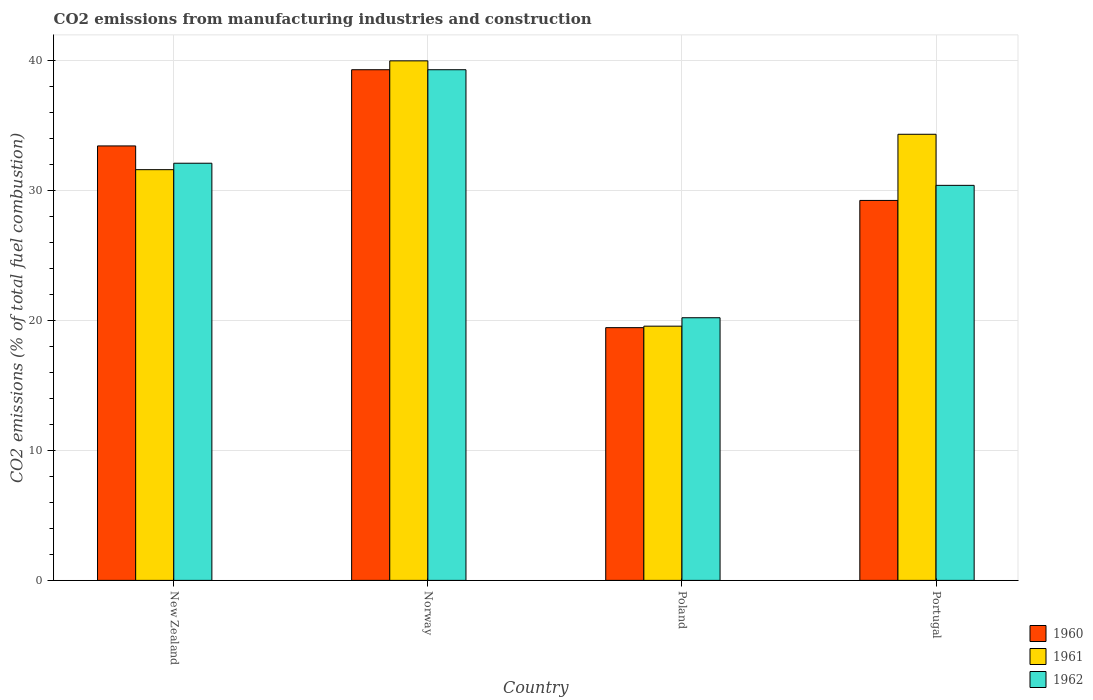How many groups of bars are there?
Ensure brevity in your answer.  4. How many bars are there on the 4th tick from the left?
Your response must be concise. 3. What is the label of the 2nd group of bars from the left?
Provide a succinct answer. Norway. In how many cases, is the number of bars for a given country not equal to the number of legend labels?
Ensure brevity in your answer.  0. What is the amount of CO2 emitted in 1960 in New Zealand?
Your answer should be very brief. 33.4. Across all countries, what is the maximum amount of CO2 emitted in 1962?
Ensure brevity in your answer.  39.26. Across all countries, what is the minimum amount of CO2 emitted in 1962?
Make the answer very short. 20.19. In which country was the amount of CO2 emitted in 1961 maximum?
Provide a short and direct response. Norway. What is the total amount of CO2 emitted in 1962 in the graph?
Your response must be concise. 121.88. What is the difference between the amount of CO2 emitted in 1962 in Norway and that in Poland?
Your answer should be very brief. 19.06. What is the difference between the amount of CO2 emitted in 1960 in Portugal and the amount of CO2 emitted in 1962 in Poland?
Your answer should be very brief. 9.02. What is the average amount of CO2 emitted in 1960 per country?
Provide a short and direct response. 30.32. What is the difference between the amount of CO2 emitted of/in 1960 and amount of CO2 emitted of/in 1961 in Poland?
Give a very brief answer. -0.11. What is the ratio of the amount of CO2 emitted in 1960 in Poland to that in Portugal?
Give a very brief answer. 0.67. What is the difference between the highest and the second highest amount of CO2 emitted in 1961?
Provide a short and direct response. 2.72. What is the difference between the highest and the lowest amount of CO2 emitted in 1961?
Your answer should be compact. 20.39. Is the sum of the amount of CO2 emitted in 1962 in New Zealand and Portugal greater than the maximum amount of CO2 emitted in 1960 across all countries?
Ensure brevity in your answer.  Yes. What does the 3rd bar from the right in Norway represents?
Your response must be concise. 1960. Does the graph contain any zero values?
Your answer should be compact. No. How many legend labels are there?
Offer a very short reply. 3. How are the legend labels stacked?
Offer a terse response. Vertical. What is the title of the graph?
Make the answer very short. CO2 emissions from manufacturing industries and construction. What is the label or title of the X-axis?
Ensure brevity in your answer.  Country. What is the label or title of the Y-axis?
Give a very brief answer. CO2 emissions (% of total fuel combustion). What is the CO2 emissions (% of total fuel combustion) of 1960 in New Zealand?
Give a very brief answer. 33.4. What is the CO2 emissions (% of total fuel combustion) in 1961 in New Zealand?
Provide a succinct answer. 31.57. What is the CO2 emissions (% of total fuel combustion) in 1962 in New Zealand?
Keep it short and to the point. 32.07. What is the CO2 emissions (% of total fuel combustion) in 1960 in Norway?
Provide a short and direct response. 39.26. What is the CO2 emissions (% of total fuel combustion) in 1961 in Norway?
Your answer should be very brief. 39.94. What is the CO2 emissions (% of total fuel combustion) of 1962 in Norway?
Make the answer very short. 39.26. What is the CO2 emissions (% of total fuel combustion) of 1960 in Poland?
Provide a succinct answer. 19.43. What is the CO2 emissions (% of total fuel combustion) in 1961 in Poland?
Provide a short and direct response. 19.54. What is the CO2 emissions (% of total fuel combustion) of 1962 in Poland?
Make the answer very short. 20.19. What is the CO2 emissions (% of total fuel combustion) of 1960 in Portugal?
Your answer should be very brief. 29.21. What is the CO2 emissions (% of total fuel combustion) in 1961 in Portugal?
Your response must be concise. 34.29. What is the CO2 emissions (% of total fuel combustion) of 1962 in Portugal?
Offer a very short reply. 30.37. Across all countries, what is the maximum CO2 emissions (% of total fuel combustion) of 1960?
Provide a short and direct response. 39.26. Across all countries, what is the maximum CO2 emissions (% of total fuel combustion) of 1961?
Your answer should be very brief. 39.94. Across all countries, what is the maximum CO2 emissions (% of total fuel combustion) of 1962?
Your answer should be compact. 39.26. Across all countries, what is the minimum CO2 emissions (% of total fuel combustion) of 1960?
Keep it short and to the point. 19.43. Across all countries, what is the minimum CO2 emissions (% of total fuel combustion) of 1961?
Your response must be concise. 19.54. Across all countries, what is the minimum CO2 emissions (% of total fuel combustion) of 1962?
Keep it short and to the point. 20.19. What is the total CO2 emissions (% of total fuel combustion) of 1960 in the graph?
Make the answer very short. 121.29. What is the total CO2 emissions (% of total fuel combustion) in 1961 in the graph?
Your answer should be compact. 125.35. What is the total CO2 emissions (% of total fuel combustion) of 1962 in the graph?
Offer a terse response. 121.88. What is the difference between the CO2 emissions (% of total fuel combustion) of 1960 in New Zealand and that in Norway?
Offer a terse response. -5.86. What is the difference between the CO2 emissions (% of total fuel combustion) of 1961 in New Zealand and that in Norway?
Give a very brief answer. -8.36. What is the difference between the CO2 emissions (% of total fuel combustion) in 1962 in New Zealand and that in Norway?
Keep it short and to the point. -7.19. What is the difference between the CO2 emissions (% of total fuel combustion) in 1960 in New Zealand and that in Poland?
Provide a succinct answer. 13.97. What is the difference between the CO2 emissions (% of total fuel combustion) in 1961 in New Zealand and that in Poland?
Your answer should be compact. 12.03. What is the difference between the CO2 emissions (% of total fuel combustion) in 1962 in New Zealand and that in Poland?
Offer a terse response. 11.88. What is the difference between the CO2 emissions (% of total fuel combustion) in 1960 in New Zealand and that in Portugal?
Ensure brevity in your answer.  4.19. What is the difference between the CO2 emissions (% of total fuel combustion) of 1961 in New Zealand and that in Portugal?
Your answer should be very brief. -2.72. What is the difference between the CO2 emissions (% of total fuel combustion) in 1962 in New Zealand and that in Portugal?
Make the answer very short. 1.7. What is the difference between the CO2 emissions (% of total fuel combustion) in 1960 in Norway and that in Poland?
Ensure brevity in your answer.  19.83. What is the difference between the CO2 emissions (% of total fuel combustion) in 1961 in Norway and that in Poland?
Keep it short and to the point. 20.39. What is the difference between the CO2 emissions (% of total fuel combustion) in 1962 in Norway and that in Poland?
Offer a very short reply. 19.06. What is the difference between the CO2 emissions (% of total fuel combustion) of 1960 in Norway and that in Portugal?
Your answer should be very brief. 10.05. What is the difference between the CO2 emissions (% of total fuel combustion) of 1961 in Norway and that in Portugal?
Provide a short and direct response. 5.64. What is the difference between the CO2 emissions (% of total fuel combustion) of 1962 in Norway and that in Portugal?
Offer a very short reply. 8.89. What is the difference between the CO2 emissions (% of total fuel combustion) of 1960 in Poland and that in Portugal?
Make the answer very short. -9.78. What is the difference between the CO2 emissions (% of total fuel combustion) of 1961 in Poland and that in Portugal?
Give a very brief answer. -14.75. What is the difference between the CO2 emissions (% of total fuel combustion) in 1962 in Poland and that in Portugal?
Your answer should be compact. -10.18. What is the difference between the CO2 emissions (% of total fuel combustion) of 1960 in New Zealand and the CO2 emissions (% of total fuel combustion) of 1961 in Norway?
Your answer should be compact. -6.54. What is the difference between the CO2 emissions (% of total fuel combustion) of 1960 in New Zealand and the CO2 emissions (% of total fuel combustion) of 1962 in Norway?
Your response must be concise. -5.86. What is the difference between the CO2 emissions (% of total fuel combustion) of 1961 in New Zealand and the CO2 emissions (% of total fuel combustion) of 1962 in Norway?
Offer a very short reply. -7.68. What is the difference between the CO2 emissions (% of total fuel combustion) of 1960 in New Zealand and the CO2 emissions (% of total fuel combustion) of 1961 in Poland?
Give a very brief answer. 13.85. What is the difference between the CO2 emissions (% of total fuel combustion) of 1960 in New Zealand and the CO2 emissions (% of total fuel combustion) of 1962 in Poland?
Keep it short and to the point. 13.21. What is the difference between the CO2 emissions (% of total fuel combustion) of 1961 in New Zealand and the CO2 emissions (% of total fuel combustion) of 1962 in Poland?
Keep it short and to the point. 11.38. What is the difference between the CO2 emissions (% of total fuel combustion) in 1960 in New Zealand and the CO2 emissions (% of total fuel combustion) in 1961 in Portugal?
Offer a very short reply. -0.9. What is the difference between the CO2 emissions (% of total fuel combustion) in 1960 in New Zealand and the CO2 emissions (% of total fuel combustion) in 1962 in Portugal?
Give a very brief answer. 3.03. What is the difference between the CO2 emissions (% of total fuel combustion) of 1961 in New Zealand and the CO2 emissions (% of total fuel combustion) of 1962 in Portugal?
Keep it short and to the point. 1.21. What is the difference between the CO2 emissions (% of total fuel combustion) in 1960 in Norway and the CO2 emissions (% of total fuel combustion) in 1961 in Poland?
Keep it short and to the point. 19.71. What is the difference between the CO2 emissions (% of total fuel combustion) of 1960 in Norway and the CO2 emissions (% of total fuel combustion) of 1962 in Poland?
Provide a succinct answer. 19.06. What is the difference between the CO2 emissions (% of total fuel combustion) of 1961 in Norway and the CO2 emissions (% of total fuel combustion) of 1962 in Poland?
Offer a very short reply. 19.75. What is the difference between the CO2 emissions (% of total fuel combustion) of 1960 in Norway and the CO2 emissions (% of total fuel combustion) of 1961 in Portugal?
Offer a very short reply. 4.96. What is the difference between the CO2 emissions (% of total fuel combustion) in 1960 in Norway and the CO2 emissions (% of total fuel combustion) in 1962 in Portugal?
Provide a succinct answer. 8.89. What is the difference between the CO2 emissions (% of total fuel combustion) in 1961 in Norway and the CO2 emissions (% of total fuel combustion) in 1962 in Portugal?
Your answer should be compact. 9.57. What is the difference between the CO2 emissions (% of total fuel combustion) in 1960 in Poland and the CO2 emissions (% of total fuel combustion) in 1961 in Portugal?
Make the answer very short. -14.87. What is the difference between the CO2 emissions (% of total fuel combustion) of 1960 in Poland and the CO2 emissions (% of total fuel combustion) of 1962 in Portugal?
Your answer should be very brief. -10.94. What is the difference between the CO2 emissions (% of total fuel combustion) of 1961 in Poland and the CO2 emissions (% of total fuel combustion) of 1962 in Portugal?
Ensure brevity in your answer.  -10.82. What is the average CO2 emissions (% of total fuel combustion) of 1960 per country?
Provide a short and direct response. 30.32. What is the average CO2 emissions (% of total fuel combustion) in 1961 per country?
Offer a very short reply. 31.34. What is the average CO2 emissions (% of total fuel combustion) in 1962 per country?
Make the answer very short. 30.47. What is the difference between the CO2 emissions (% of total fuel combustion) of 1960 and CO2 emissions (% of total fuel combustion) of 1961 in New Zealand?
Your answer should be compact. 1.82. What is the difference between the CO2 emissions (% of total fuel combustion) in 1960 and CO2 emissions (% of total fuel combustion) in 1962 in New Zealand?
Keep it short and to the point. 1.33. What is the difference between the CO2 emissions (% of total fuel combustion) of 1961 and CO2 emissions (% of total fuel combustion) of 1962 in New Zealand?
Provide a succinct answer. -0.49. What is the difference between the CO2 emissions (% of total fuel combustion) of 1960 and CO2 emissions (% of total fuel combustion) of 1961 in Norway?
Ensure brevity in your answer.  -0.68. What is the difference between the CO2 emissions (% of total fuel combustion) of 1960 and CO2 emissions (% of total fuel combustion) of 1962 in Norway?
Offer a terse response. 0. What is the difference between the CO2 emissions (% of total fuel combustion) in 1961 and CO2 emissions (% of total fuel combustion) in 1962 in Norway?
Ensure brevity in your answer.  0.68. What is the difference between the CO2 emissions (% of total fuel combustion) of 1960 and CO2 emissions (% of total fuel combustion) of 1961 in Poland?
Give a very brief answer. -0.11. What is the difference between the CO2 emissions (% of total fuel combustion) in 1960 and CO2 emissions (% of total fuel combustion) in 1962 in Poland?
Provide a succinct answer. -0.76. What is the difference between the CO2 emissions (% of total fuel combustion) in 1961 and CO2 emissions (% of total fuel combustion) in 1962 in Poland?
Keep it short and to the point. -0.65. What is the difference between the CO2 emissions (% of total fuel combustion) in 1960 and CO2 emissions (% of total fuel combustion) in 1961 in Portugal?
Your answer should be very brief. -5.09. What is the difference between the CO2 emissions (% of total fuel combustion) of 1960 and CO2 emissions (% of total fuel combustion) of 1962 in Portugal?
Offer a very short reply. -1.16. What is the difference between the CO2 emissions (% of total fuel combustion) in 1961 and CO2 emissions (% of total fuel combustion) in 1962 in Portugal?
Your response must be concise. 3.93. What is the ratio of the CO2 emissions (% of total fuel combustion) in 1960 in New Zealand to that in Norway?
Your answer should be compact. 0.85. What is the ratio of the CO2 emissions (% of total fuel combustion) of 1961 in New Zealand to that in Norway?
Your response must be concise. 0.79. What is the ratio of the CO2 emissions (% of total fuel combustion) in 1962 in New Zealand to that in Norway?
Keep it short and to the point. 0.82. What is the ratio of the CO2 emissions (% of total fuel combustion) of 1960 in New Zealand to that in Poland?
Ensure brevity in your answer.  1.72. What is the ratio of the CO2 emissions (% of total fuel combustion) in 1961 in New Zealand to that in Poland?
Offer a terse response. 1.62. What is the ratio of the CO2 emissions (% of total fuel combustion) of 1962 in New Zealand to that in Poland?
Ensure brevity in your answer.  1.59. What is the ratio of the CO2 emissions (% of total fuel combustion) in 1960 in New Zealand to that in Portugal?
Provide a short and direct response. 1.14. What is the ratio of the CO2 emissions (% of total fuel combustion) of 1961 in New Zealand to that in Portugal?
Provide a short and direct response. 0.92. What is the ratio of the CO2 emissions (% of total fuel combustion) in 1962 in New Zealand to that in Portugal?
Your response must be concise. 1.06. What is the ratio of the CO2 emissions (% of total fuel combustion) of 1960 in Norway to that in Poland?
Your answer should be compact. 2.02. What is the ratio of the CO2 emissions (% of total fuel combustion) in 1961 in Norway to that in Poland?
Give a very brief answer. 2.04. What is the ratio of the CO2 emissions (% of total fuel combustion) of 1962 in Norway to that in Poland?
Keep it short and to the point. 1.94. What is the ratio of the CO2 emissions (% of total fuel combustion) in 1960 in Norway to that in Portugal?
Provide a short and direct response. 1.34. What is the ratio of the CO2 emissions (% of total fuel combustion) in 1961 in Norway to that in Portugal?
Your response must be concise. 1.16. What is the ratio of the CO2 emissions (% of total fuel combustion) of 1962 in Norway to that in Portugal?
Offer a very short reply. 1.29. What is the ratio of the CO2 emissions (% of total fuel combustion) of 1960 in Poland to that in Portugal?
Your response must be concise. 0.67. What is the ratio of the CO2 emissions (% of total fuel combustion) of 1961 in Poland to that in Portugal?
Offer a very short reply. 0.57. What is the ratio of the CO2 emissions (% of total fuel combustion) in 1962 in Poland to that in Portugal?
Your response must be concise. 0.66. What is the difference between the highest and the second highest CO2 emissions (% of total fuel combustion) in 1960?
Keep it short and to the point. 5.86. What is the difference between the highest and the second highest CO2 emissions (% of total fuel combustion) of 1961?
Offer a very short reply. 5.64. What is the difference between the highest and the second highest CO2 emissions (% of total fuel combustion) of 1962?
Provide a short and direct response. 7.19. What is the difference between the highest and the lowest CO2 emissions (% of total fuel combustion) of 1960?
Offer a terse response. 19.83. What is the difference between the highest and the lowest CO2 emissions (% of total fuel combustion) in 1961?
Your response must be concise. 20.39. What is the difference between the highest and the lowest CO2 emissions (% of total fuel combustion) in 1962?
Keep it short and to the point. 19.06. 